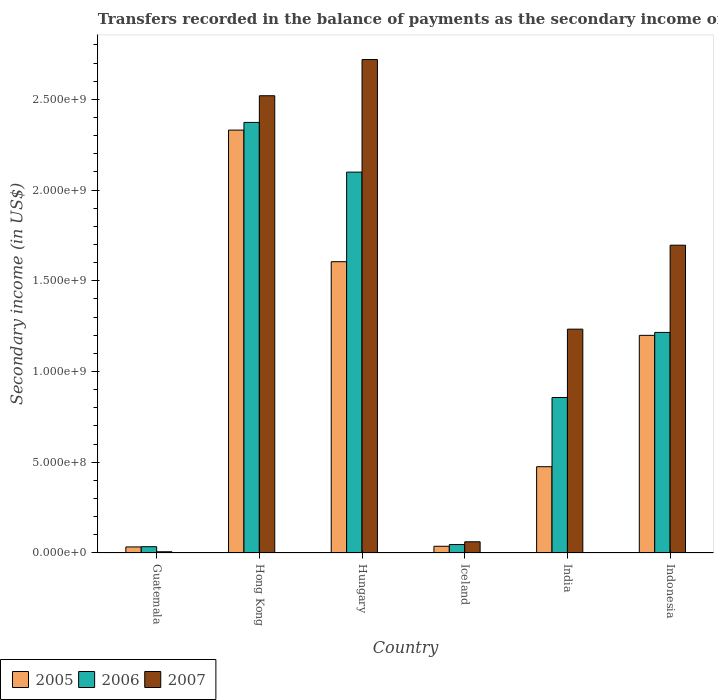How many different coloured bars are there?
Your answer should be very brief. 3. How many groups of bars are there?
Provide a short and direct response. 6. How many bars are there on the 1st tick from the right?
Give a very brief answer. 3. What is the label of the 6th group of bars from the left?
Your response must be concise. Indonesia. What is the secondary income of in 2005 in India?
Offer a terse response. 4.76e+08. Across all countries, what is the maximum secondary income of in 2005?
Your answer should be compact. 2.33e+09. Across all countries, what is the minimum secondary income of in 2005?
Offer a terse response. 3.34e+07. In which country was the secondary income of in 2006 maximum?
Give a very brief answer. Hong Kong. In which country was the secondary income of in 2006 minimum?
Make the answer very short. Guatemala. What is the total secondary income of in 2006 in the graph?
Provide a short and direct response. 6.63e+09. What is the difference between the secondary income of in 2007 in Guatemala and that in Hungary?
Give a very brief answer. -2.71e+09. What is the difference between the secondary income of in 2007 in India and the secondary income of in 2005 in Guatemala?
Offer a terse response. 1.20e+09. What is the average secondary income of in 2005 per country?
Make the answer very short. 9.47e+08. What is the difference between the secondary income of of/in 2005 and secondary income of of/in 2006 in India?
Provide a short and direct response. -3.82e+08. What is the ratio of the secondary income of in 2007 in Hong Kong to that in Iceland?
Keep it short and to the point. 40.8. Is the difference between the secondary income of in 2005 in Guatemala and Hungary greater than the difference between the secondary income of in 2006 in Guatemala and Hungary?
Offer a very short reply. Yes. What is the difference between the highest and the second highest secondary income of in 2006?
Ensure brevity in your answer.  8.84e+08. What is the difference between the highest and the lowest secondary income of in 2005?
Your answer should be compact. 2.30e+09. Is the sum of the secondary income of in 2005 in Iceland and India greater than the maximum secondary income of in 2006 across all countries?
Ensure brevity in your answer.  No. What does the 3rd bar from the right in Hong Kong represents?
Provide a succinct answer. 2005. Is it the case that in every country, the sum of the secondary income of in 2006 and secondary income of in 2005 is greater than the secondary income of in 2007?
Provide a short and direct response. Yes. Where does the legend appear in the graph?
Provide a succinct answer. Bottom left. What is the title of the graph?
Offer a very short reply. Transfers recorded in the balance of payments as the secondary income of a country. Does "2007" appear as one of the legend labels in the graph?
Your answer should be compact. Yes. What is the label or title of the Y-axis?
Your answer should be compact. Secondary income (in US$). What is the Secondary income (in US$) of 2005 in Guatemala?
Offer a very short reply. 3.34e+07. What is the Secondary income (in US$) in 2006 in Guatemala?
Provide a succinct answer. 3.47e+07. What is the Secondary income (in US$) in 2007 in Guatemala?
Offer a very short reply. 6.70e+06. What is the Secondary income (in US$) in 2005 in Hong Kong?
Ensure brevity in your answer.  2.33e+09. What is the Secondary income (in US$) of 2006 in Hong Kong?
Offer a very short reply. 2.37e+09. What is the Secondary income (in US$) in 2007 in Hong Kong?
Make the answer very short. 2.52e+09. What is the Secondary income (in US$) of 2005 in Hungary?
Ensure brevity in your answer.  1.61e+09. What is the Secondary income (in US$) in 2006 in Hungary?
Provide a succinct answer. 2.10e+09. What is the Secondary income (in US$) in 2007 in Hungary?
Your answer should be compact. 2.72e+09. What is the Secondary income (in US$) in 2005 in Iceland?
Provide a succinct answer. 3.70e+07. What is the Secondary income (in US$) of 2006 in Iceland?
Keep it short and to the point. 4.65e+07. What is the Secondary income (in US$) of 2007 in Iceland?
Your answer should be very brief. 6.18e+07. What is the Secondary income (in US$) of 2005 in India?
Provide a succinct answer. 4.76e+08. What is the Secondary income (in US$) in 2006 in India?
Keep it short and to the point. 8.57e+08. What is the Secondary income (in US$) of 2007 in India?
Provide a short and direct response. 1.23e+09. What is the Secondary income (in US$) of 2005 in Indonesia?
Provide a short and direct response. 1.20e+09. What is the Secondary income (in US$) of 2006 in Indonesia?
Your response must be concise. 1.22e+09. What is the Secondary income (in US$) of 2007 in Indonesia?
Offer a very short reply. 1.70e+09. Across all countries, what is the maximum Secondary income (in US$) in 2005?
Offer a terse response. 2.33e+09. Across all countries, what is the maximum Secondary income (in US$) in 2006?
Your answer should be very brief. 2.37e+09. Across all countries, what is the maximum Secondary income (in US$) of 2007?
Provide a short and direct response. 2.72e+09. Across all countries, what is the minimum Secondary income (in US$) of 2005?
Offer a terse response. 3.34e+07. Across all countries, what is the minimum Secondary income (in US$) in 2006?
Provide a succinct answer. 3.47e+07. Across all countries, what is the minimum Secondary income (in US$) of 2007?
Your answer should be compact. 6.70e+06. What is the total Secondary income (in US$) of 2005 in the graph?
Give a very brief answer. 5.68e+09. What is the total Secondary income (in US$) of 2006 in the graph?
Provide a short and direct response. 6.63e+09. What is the total Secondary income (in US$) in 2007 in the graph?
Your answer should be compact. 8.24e+09. What is the difference between the Secondary income (in US$) of 2005 in Guatemala and that in Hong Kong?
Your answer should be very brief. -2.30e+09. What is the difference between the Secondary income (in US$) of 2006 in Guatemala and that in Hong Kong?
Keep it short and to the point. -2.34e+09. What is the difference between the Secondary income (in US$) of 2007 in Guatemala and that in Hong Kong?
Keep it short and to the point. -2.51e+09. What is the difference between the Secondary income (in US$) of 2005 in Guatemala and that in Hungary?
Your answer should be very brief. -1.57e+09. What is the difference between the Secondary income (in US$) of 2006 in Guatemala and that in Hungary?
Provide a succinct answer. -2.06e+09. What is the difference between the Secondary income (in US$) of 2007 in Guatemala and that in Hungary?
Keep it short and to the point. -2.71e+09. What is the difference between the Secondary income (in US$) in 2005 in Guatemala and that in Iceland?
Offer a terse response. -3.57e+06. What is the difference between the Secondary income (in US$) of 2006 in Guatemala and that in Iceland?
Ensure brevity in your answer.  -1.18e+07. What is the difference between the Secondary income (in US$) of 2007 in Guatemala and that in Iceland?
Give a very brief answer. -5.51e+07. What is the difference between the Secondary income (in US$) in 2005 in Guatemala and that in India?
Offer a very short reply. -4.42e+08. What is the difference between the Secondary income (in US$) of 2006 in Guatemala and that in India?
Your response must be concise. -8.22e+08. What is the difference between the Secondary income (in US$) in 2007 in Guatemala and that in India?
Your response must be concise. -1.23e+09. What is the difference between the Secondary income (in US$) in 2005 in Guatemala and that in Indonesia?
Offer a terse response. -1.17e+09. What is the difference between the Secondary income (in US$) of 2006 in Guatemala and that in Indonesia?
Your response must be concise. -1.18e+09. What is the difference between the Secondary income (in US$) in 2007 in Guatemala and that in Indonesia?
Give a very brief answer. -1.69e+09. What is the difference between the Secondary income (in US$) of 2005 in Hong Kong and that in Hungary?
Your response must be concise. 7.25e+08. What is the difference between the Secondary income (in US$) in 2006 in Hong Kong and that in Hungary?
Your answer should be compact. 2.74e+08. What is the difference between the Secondary income (in US$) of 2007 in Hong Kong and that in Hungary?
Give a very brief answer. -1.99e+08. What is the difference between the Secondary income (in US$) of 2005 in Hong Kong and that in Iceland?
Your answer should be very brief. 2.29e+09. What is the difference between the Secondary income (in US$) of 2006 in Hong Kong and that in Iceland?
Your answer should be compact. 2.33e+09. What is the difference between the Secondary income (in US$) of 2007 in Hong Kong and that in Iceland?
Your response must be concise. 2.46e+09. What is the difference between the Secondary income (in US$) in 2005 in Hong Kong and that in India?
Provide a succinct answer. 1.86e+09. What is the difference between the Secondary income (in US$) of 2006 in Hong Kong and that in India?
Your response must be concise. 1.52e+09. What is the difference between the Secondary income (in US$) in 2007 in Hong Kong and that in India?
Provide a succinct answer. 1.29e+09. What is the difference between the Secondary income (in US$) in 2005 in Hong Kong and that in Indonesia?
Your response must be concise. 1.13e+09. What is the difference between the Secondary income (in US$) of 2006 in Hong Kong and that in Indonesia?
Offer a very short reply. 1.16e+09. What is the difference between the Secondary income (in US$) of 2007 in Hong Kong and that in Indonesia?
Your response must be concise. 8.24e+08. What is the difference between the Secondary income (in US$) in 2005 in Hungary and that in Iceland?
Ensure brevity in your answer.  1.57e+09. What is the difference between the Secondary income (in US$) in 2006 in Hungary and that in Iceland?
Provide a short and direct response. 2.05e+09. What is the difference between the Secondary income (in US$) in 2007 in Hungary and that in Iceland?
Provide a short and direct response. 2.66e+09. What is the difference between the Secondary income (in US$) of 2005 in Hungary and that in India?
Provide a succinct answer. 1.13e+09. What is the difference between the Secondary income (in US$) in 2006 in Hungary and that in India?
Give a very brief answer. 1.24e+09. What is the difference between the Secondary income (in US$) in 2007 in Hungary and that in India?
Your answer should be compact. 1.49e+09. What is the difference between the Secondary income (in US$) in 2005 in Hungary and that in Indonesia?
Give a very brief answer. 4.06e+08. What is the difference between the Secondary income (in US$) in 2006 in Hungary and that in Indonesia?
Your answer should be very brief. 8.84e+08. What is the difference between the Secondary income (in US$) in 2007 in Hungary and that in Indonesia?
Your answer should be very brief. 1.02e+09. What is the difference between the Secondary income (in US$) of 2005 in Iceland and that in India?
Give a very brief answer. -4.39e+08. What is the difference between the Secondary income (in US$) of 2006 in Iceland and that in India?
Your answer should be very brief. -8.11e+08. What is the difference between the Secondary income (in US$) in 2007 in Iceland and that in India?
Provide a short and direct response. -1.17e+09. What is the difference between the Secondary income (in US$) in 2005 in Iceland and that in Indonesia?
Provide a succinct answer. -1.16e+09. What is the difference between the Secondary income (in US$) in 2006 in Iceland and that in Indonesia?
Offer a terse response. -1.17e+09. What is the difference between the Secondary income (in US$) in 2007 in Iceland and that in Indonesia?
Make the answer very short. -1.63e+09. What is the difference between the Secondary income (in US$) in 2005 in India and that in Indonesia?
Provide a short and direct response. -7.24e+08. What is the difference between the Secondary income (in US$) of 2006 in India and that in Indonesia?
Make the answer very short. -3.59e+08. What is the difference between the Secondary income (in US$) of 2007 in India and that in Indonesia?
Keep it short and to the point. -4.63e+08. What is the difference between the Secondary income (in US$) of 2005 in Guatemala and the Secondary income (in US$) of 2006 in Hong Kong?
Your answer should be compact. -2.34e+09. What is the difference between the Secondary income (in US$) in 2005 in Guatemala and the Secondary income (in US$) in 2007 in Hong Kong?
Provide a succinct answer. -2.49e+09. What is the difference between the Secondary income (in US$) of 2006 in Guatemala and the Secondary income (in US$) of 2007 in Hong Kong?
Provide a short and direct response. -2.49e+09. What is the difference between the Secondary income (in US$) of 2005 in Guatemala and the Secondary income (in US$) of 2006 in Hungary?
Your response must be concise. -2.07e+09. What is the difference between the Secondary income (in US$) of 2005 in Guatemala and the Secondary income (in US$) of 2007 in Hungary?
Make the answer very short. -2.69e+09. What is the difference between the Secondary income (in US$) in 2006 in Guatemala and the Secondary income (in US$) in 2007 in Hungary?
Give a very brief answer. -2.69e+09. What is the difference between the Secondary income (in US$) in 2005 in Guatemala and the Secondary income (in US$) in 2006 in Iceland?
Provide a succinct answer. -1.31e+07. What is the difference between the Secondary income (in US$) of 2005 in Guatemala and the Secondary income (in US$) of 2007 in Iceland?
Offer a terse response. -2.84e+07. What is the difference between the Secondary income (in US$) of 2006 in Guatemala and the Secondary income (in US$) of 2007 in Iceland?
Make the answer very short. -2.71e+07. What is the difference between the Secondary income (in US$) of 2005 in Guatemala and the Secondary income (in US$) of 2006 in India?
Make the answer very short. -8.24e+08. What is the difference between the Secondary income (in US$) in 2005 in Guatemala and the Secondary income (in US$) in 2007 in India?
Keep it short and to the point. -1.20e+09. What is the difference between the Secondary income (in US$) in 2006 in Guatemala and the Secondary income (in US$) in 2007 in India?
Ensure brevity in your answer.  -1.20e+09. What is the difference between the Secondary income (in US$) in 2005 in Guatemala and the Secondary income (in US$) in 2006 in Indonesia?
Ensure brevity in your answer.  -1.18e+09. What is the difference between the Secondary income (in US$) of 2005 in Guatemala and the Secondary income (in US$) of 2007 in Indonesia?
Your response must be concise. -1.66e+09. What is the difference between the Secondary income (in US$) in 2006 in Guatemala and the Secondary income (in US$) in 2007 in Indonesia?
Offer a terse response. -1.66e+09. What is the difference between the Secondary income (in US$) of 2005 in Hong Kong and the Secondary income (in US$) of 2006 in Hungary?
Your answer should be very brief. 2.32e+08. What is the difference between the Secondary income (in US$) in 2005 in Hong Kong and the Secondary income (in US$) in 2007 in Hungary?
Provide a succinct answer. -3.89e+08. What is the difference between the Secondary income (in US$) in 2006 in Hong Kong and the Secondary income (in US$) in 2007 in Hungary?
Give a very brief answer. -3.47e+08. What is the difference between the Secondary income (in US$) in 2005 in Hong Kong and the Secondary income (in US$) in 2006 in Iceland?
Ensure brevity in your answer.  2.28e+09. What is the difference between the Secondary income (in US$) in 2005 in Hong Kong and the Secondary income (in US$) in 2007 in Iceland?
Your answer should be very brief. 2.27e+09. What is the difference between the Secondary income (in US$) in 2006 in Hong Kong and the Secondary income (in US$) in 2007 in Iceland?
Your answer should be compact. 2.31e+09. What is the difference between the Secondary income (in US$) in 2005 in Hong Kong and the Secondary income (in US$) in 2006 in India?
Ensure brevity in your answer.  1.47e+09. What is the difference between the Secondary income (in US$) in 2005 in Hong Kong and the Secondary income (in US$) in 2007 in India?
Offer a terse response. 1.10e+09. What is the difference between the Secondary income (in US$) in 2006 in Hong Kong and the Secondary income (in US$) in 2007 in India?
Offer a very short reply. 1.14e+09. What is the difference between the Secondary income (in US$) in 2005 in Hong Kong and the Secondary income (in US$) in 2006 in Indonesia?
Offer a terse response. 1.12e+09. What is the difference between the Secondary income (in US$) in 2005 in Hong Kong and the Secondary income (in US$) in 2007 in Indonesia?
Your answer should be very brief. 6.34e+08. What is the difference between the Secondary income (in US$) in 2006 in Hong Kong and the Secondary income (in US$) in 2007 in Indonesia?
Offer a very short reply. 6.77e+08. What is the difference between the Secondary income (in US$) of 2005 in Hungary and the Secondary income (in US$) of 2006 in Iceland?
Your answer should be very brief. 1.56e+09. What is the difference between the Secondary income (in US$) in 2005 in Hungary and the Secondary income (in US$) in 2007 in Iceland?
Provide a short and direct response. 1.54e+09. What is the difference between the Secondary income (in US$) of 2006 in Hungary and the Secondary income (in US$) of 2007 in Iceland?
Ensure brevity in your answer.  2.04e+09. What is the difference between the Secondary income (in US$) in 2005 in Hungary and the Secondary income (in US$) in 2006 in India?
Make the answer very short. 7.49e+08. What is the difference between the Secondary income (in US$) in 2005 in Hungary and the Secondary income (in US$) in 2007 in India?
Make the answer very short. 3.72e+08. What is the difference between the Secondary income (in US$) in 2006 in Hungary and the Secondary income (in US$) in 2007 in India?
Ensure brevity in your answer.  8.66e+08. What is the difference between the Secondary income (in US$) in 2005 in Hungary and the Secondary income (in US$) in 2006 in Indonesia?
Provide a succinct answer. 3.90e+08. What is the difference between the Secondary income (in US$) in 2005 in Hungary and the Secondary income (in US$) in 2007 in Indonesia?
Keep it short and to the point. -9.09e+07. What is the difference between the Secondary income (in US$) of 2006 in Hungary and the Secondary income (in US$) of 2007 in Indonesia?
Your response must be concise. 4.03e+08. What is the difference between the Secondary income (in US$) of 2005 in Iceland and the Secondary income (in US$) of 2006 in India?
Provide a short and direct response. -8.20e+08. What is the difference between the Secondary income (in US$) in 2005 in Iceland and the Secondary income (in US$) in 2007 in India?
Your answer should be very brief. -1.20e+09. What is the difference between the Secondary income (in US$) of 2006 in Iceland and the Secondary income (in US$) of 2007 in India?
Make the answer very short. -1.19e+09. What is the difference between the Secondary income (in US$) of 2005 in Iceland and the Secondary income (in US$) of 2006 in Indonesia?
Give a very brief answer. -1.18e+09. What is the difference between the Secondary income (in US$) of 2005 in Iceland and the Secondary income (in US$) of 2007 in Indonesia?
Ensure brevity in your answer.  -1.66e+09. What is the difference between the Secondary income (in US$) in 2006 in Iceland and the Secondary income (in US$) in 2007 in Indonesia?
Your answer should be very brief. -1.65e+09. What is the difference between the Secondary income (in US$) in 2005 in India and the Secondary income (in US$) in 2006 in Indonesia?
Offer a terse response. -7.40e+08. What is the difference between the Secondary income (in US$) in 2005 in India and the Secondary income (in US$) in 2007 in Indonesia?
Your answer should be compact. -1.22e+09. What is the difference between the Secondary income (in US$) of 2006 in India and the Secondary income (in US$) of 2007 in Indonesia?
Give a very brief answer. -8.39e+08. What is the average Secondary income (in US$) in 2005 per country?
Your answer should be very brief. 9.47e+08. What is the average Secondary income (in US$) in 2006 per country?
Your response must be concise. 1.10e+09. What is the average Secondary income (in US$) in 2007 per country?
Provide a short and direct response. 1.37e+09. What is the difference between the Secondary income (in US$) of 2005 and Secondary income (in US$) of 2006 in Guatemala?
Make the answer very short. -1.30e+06. What is the difference between the Secondary income (in US$) of 2005 and Secondary income (in US$) of 2007 in Guatemala?
Offer a very short reply. 2.67e+07. What is the difference between the Secondary income (in US$) of 2006 and Secondary income (in US$) of 2007 in Guatemala?
Provide a short and direct response. 2.80e+07. What is the difference between the Secondary income (in US$) of 2005 and Secondary income (in US$) of 2006 in Hong Kong?
Provide a succinct answer. -4.24e+07. What is the difference between the Secondary income (in US$) in 2005 and Secondary income (in US$) in 2007 in Hong Kong?
Your answer should be very brief. -1.89e+08. What is the difference between the Secondary income (in US$) of 2006 and Secondary income (in US$) of 2007 in Hong Kong?
Your answer should be very brief. -1.47e+08. What is the difference between the Secondary income (in US$) in 2005 and Secondary income (in US$) in 2006 in Hungary?
Provide a short and direct response. -4.94e+08. What is the difference between the Secondary income (in US$) in 2005 and Secondary income (in US$) in 2007 in Hungary?
Your answer should be very brief. -1.11e+09. What is the difference between the Secondary income (in US$) in 2006 and Secondary income (in US$) in 2007 in Hungary?
Provide a short and direct response. -6.20e+08. What is the difference between the Secondary income (in US$) of 2005 and Secondary income (in US$) of 2006 in Iceland?
Your answer should be compact. -9.48e+06. What is the difference between the Secondary income (in US$) in 2005 and Secondary income (in US$) in 2007 in Iceland?
Ensure brevity in your answer.  -2.48e+07. What is the difference between the Secondary income (in US$) of 2006 and Secondary income (in US$) of 2007 in Iceland?
Provide a succinct answer. -1.53e+07. What is the difference between the Secondary income (in US$) of 2005 and Secondary income (in US$) of 2006 in India?
Provide a short and direct response. -3.82e+08. What is the difference between the Secondary income (in US$) of 2005 and Secondary income (in US$) of 2007 in India?
Provide a succinct answer. -7.58e+08. What is the difference between the Secondary income (in US$) of 2006 and Secondary income (in US$) of 2007 in India?
Make the answer very short. -3.77e+08. What is the difference between the Secondary income (in US$) in 2005 and Secondary income (in US$) in 2006 in Indonesia?
Offer a terse response. -1.61e+07. What is the difference between the Secondary income (in US$) in 2005 and Secondary income (in US$) in 2007 in Indonesia?
Ensure brevity in your answer.  -4.97e+08. What is the difference between the Secondary income (in US$) in 2006 and Secondary income (in US$) in 2007 in Indonesia?
Ensure brevity in your answer.  -4.81e+08. What is the ratio of the Secondary income (in US$) in 2005 in Guatemala to that in Hong Kong?
Your answer should be very brief. 0.01. What is the ratio of the Secondary income (in US$) of 2006 in Guatemala to that in Hong Kong?
Offer a very short reply. 0.01. What is the ratio of the Secondary income (in US$) in 2007 in Guatemala to that in Hong Kong?
Give a very brief answer. 0. What is the ratio of the Secondary income (in US$) of 2005 in Guatemala to that in Hungary?
Provide a succinct answer. 0.02. What is the ratio of the Secondary income (in US$) of 2006 in Guatemala to that in Hungary?
Provide a succinct answer. 0.02. What is the ratio of the Secondary income (in US$) in 2007 in Guatemala to that in Hungary?
Keep it short and to the point. 0. What is the ratio of the Secondary income (in US$) of 2005 in Guatemala to that in Iceland?
Provide a short and direct response. 0.9. What is the ratio of the Secondary income (in US$) in 2006 in Guatemala to that in Iceland?
Your answer should be very brief. 0.75. What is the ratio of the Secondary income (in US$) of 2007 in Guatemala to that in Iceland?
Your answer should be very brief. 0.11. What is the ratio of the Secondary income (in US$) in 2005 in Guatemala to that in India?
Provide a succinct answer. 0.07. What is the ratio of the Secondary income (in US$) in 2006 in Guatemala to that in India?
Your answer should be compact. 0.04. What is the ratio of the Secondary income (in US$) of 2007 in Guatemala to that in India?
Offer a very short reply. 0.01. What is the ratio of the Secondary income (in US$) of 2005 in Guatemala to that in Indonesia?
Offer a terse response. 0.03. What is the ratio of the Secondary income (in US$) in 2006 in Guatemala to that in Indonesia?
Ensure brevity in your answer.  0.03. What is the ratio of the Secondary income (in US$) in 2007 in Guatemala to that in Indonesia?
Keep it short and to the point. 0. What is the ratio of the Secondary income (in US$) in 2005 in Hong Kong to that in Hungary?
Your answer should be compact. 1.45. What is the ratio of the Secondary income (in US$) of 2006 in Hong Kong to that in Hungary?
Provide a short and direct response. 1.13. What is the ratio of the Secondary income (in US$) in 2007 in Hong Kong to that in Hungary?
Your answer should be very brief. 0.93. What is the ratio of the Secondary income (in US$) of 2005 in Hong Kong to that in Iceland?
Provide a succinct answer. 63.04. What is the ratio of the Secondary income (in US$) of 2006 in Hong Kong to that in Iceland?
Give a very brief answer. 51.09. What is the ratio of the Secondary income (in US$) in 2007 in Hong Kong to that in Iceland?
Provide a short and direct response. 40.8. What is the ratio of the Secondary income (in US$) in 2005 in Hong Kong to that in India?
Your answer should be compact. 4.9. What is the ratio of the Secondary income (in US$) of 2006 in Hong Kong to that in India?
Provide a succinct answer. 2.77. What is the ratio of the Secondary income (in US$) in 2007 in Hong Kong to that in India?
Offer a very short reply. 2.04. What is the ratio of the Secondary income (in US$) in 2005 in Hong Kong to that in Indonesia?
Your answer should be compact. 1.94. What is the ratio of the Secondary income (in US$) in 2006 in Hong Kong to that in Indonesia?
Your answer should be very brief. 1.95. What is the ratio of the Secondary income (in US$) in 2007 in Hong Kong to that in Indonesia?
Offer a terse response. 1.49. What is the ratio of the Secondary income (in US$) of 2005 in Hungary to that in Iceland?
Make the answer very short. 43.42. What is the ratio of the Secondary income (in US$) in 2006 in Hungary to that in Iceland?
Ensure brevity in your answer.  45.19. What is the ratio of the Secondary income (in US$) in 2007 in Hungary to that in Iceland?
Make the answer very short. 44.03. What is the ratio of the Secondary income (in US$) of 2005 in Hungary to that in India?
Your answer should be compact. 3.38. What is the ratio of the Secondary income (in US$) in 2006 in Hungary to that in India?
Provide a short and direct response. 2.45. What is the ratio of the Secondary income (in US$) of 2007 in Hungary to that in India?
Provide a succinct answer. 2.2. What is the ratio of the Secondary income (in US$) of 2005 in Hungary to that in Indonesia?
Make the answer very short. 1.34. What is the ratio of the Secondary income (in US$) in 2006 in Hungary to that in Indonesia?
Your answer should be compact. 1.73. What is the ratio of the Secondary income (in US$) in 2007 in Hungary to that in Indonesia?
Give a very brief answer. 1.6. What is the ratio of the Secondary income (in US$) of 2005 in Iceland to that in India?
Ensure brevity in your answer.  0.08. What is the ratio of the Secondary income (in US$) in 2006 in Iceland to that in India?
Your answer should be very brief. 0.05. What is the ratio of the Secondary income (in US$) of 2007 in Iceland to that in India?
Offer a terse response. 0.05. What is the ratio of the Secondary income (in US$) of 2005 in Iceland to that in Indonesia?
Your response must be concise. 0.03. What is the ratio of the Secondary income (in US$) in 2006 in Iceland to that in Indonesia?
Keep it short and to the point. 0.04. What is the ratio of the Secondary income (in US$) of 2007 in Iceland to that in Indonesia?
Make the answer very short. 0.04. What is the ratio of the Secondary income (in US$) in 2005 in India to that in Indonesia?
Your response must be concise. 0.4. What is the ratio of the Secondary income (in US$) in 2006 in India to that in Indonesia?
Ensure brevity in your answer.  0.7. What is the ratio of the Secondary income (in US$) in 2007 in India to that in Indonesia?
Your answer should be compact. 0.73. What is the difference between the highest and the second highest Secondary income (in US$) of 2005?
Provide a short and direct response. 7.25e+08. What is the difference between the highest and the second highest Secondary income (in US$) in 2006?
Your answer should be compact. 2.74e+08. What is the difference between the highest and the second highest Secondary income (in US$) in 2007?
Make the answer very short. 1.99e+08. What is the difference between the highest and the lowest Secondary income (in US$) in 2005?
Offer a very short reply. 2.30e+09. What is the difference between the highest and the lowest Secondary income (in US$) of 2006?
Give a very brief answer. 2.34e+09. What is the difference between the highest and the lowest Secondary income (in US$) in 2007?
Make the answer very short. 2.71e+09. 